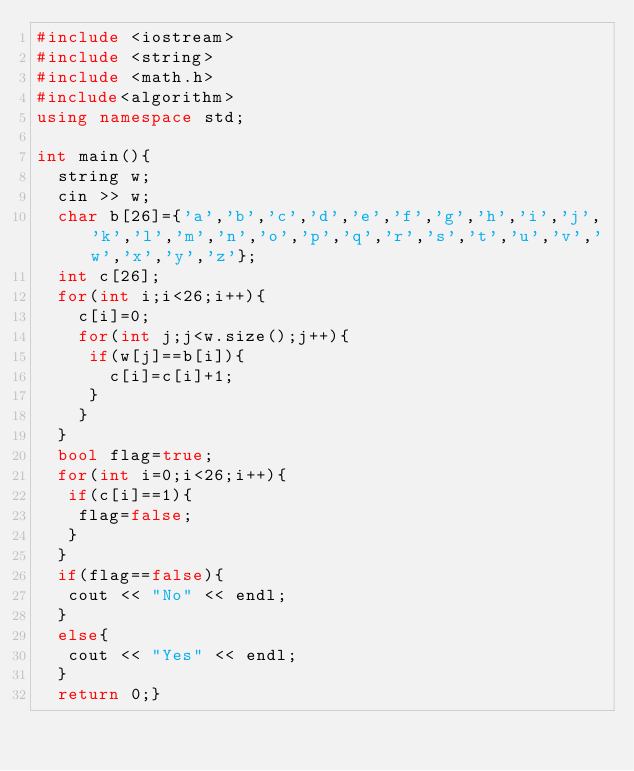<code> <loc_0><loc_0><loc_500><loc_500><_C++_>#include <iostream>
#include <string>
#include <math.h>
#include<algorithm>
using namespace std;
 
int main(){
  string w;
  cin >> w;
  char b[26]={'a','b','c','d','e','f','g','h','i','j','k','l','m','n','o','p','q','r','s','t','u','v','w','x','y','z'};
  int c[26];
  for(int i;i<26;i++){
    c[i]=0;
    for(int j;j<w.size();j++){
     if(w[j]==b[i]){
       c[i]=c[i]+1;
     }
    }
  }
  bool flag=true;
  for(int i=0;i<26;i++){
   if(c[i]==1){
    flag=false; 
   }
  }
  if(flag==false){
   cout << "No" << endl; 
  }
  else{
   cout << "Yes" << endl; 
  }
  return 0;}</code> 